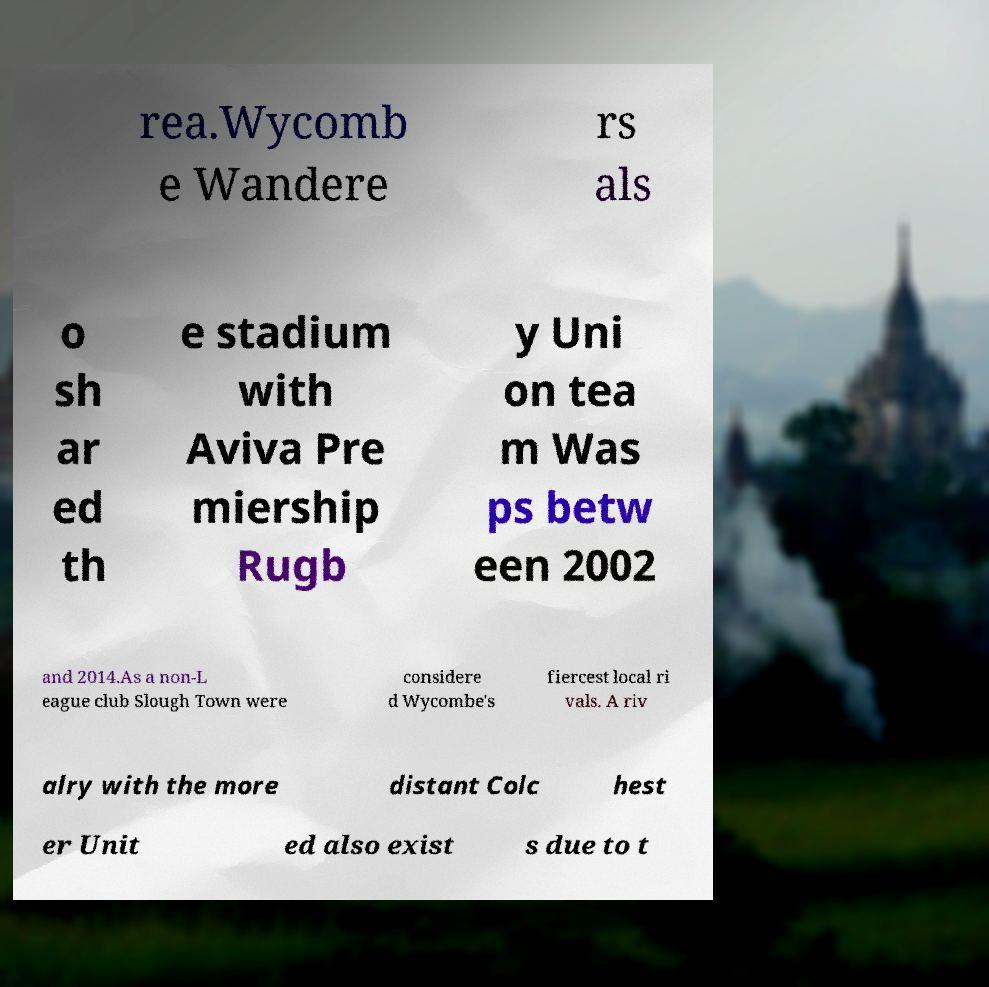Could you extract and type out the text from this image? rea.Wycomb e Wandere rs als o sh ar ed th e stadium with Aviva Pre miership Rugb y Uni on tea m Was ps betw een 2002 and 2014.As a non-L eague club Slough Town were considere d Wycombe's fiercest local ri vals. A riv alry with the more distant Colc hest er Unit ed also exist s due to t 